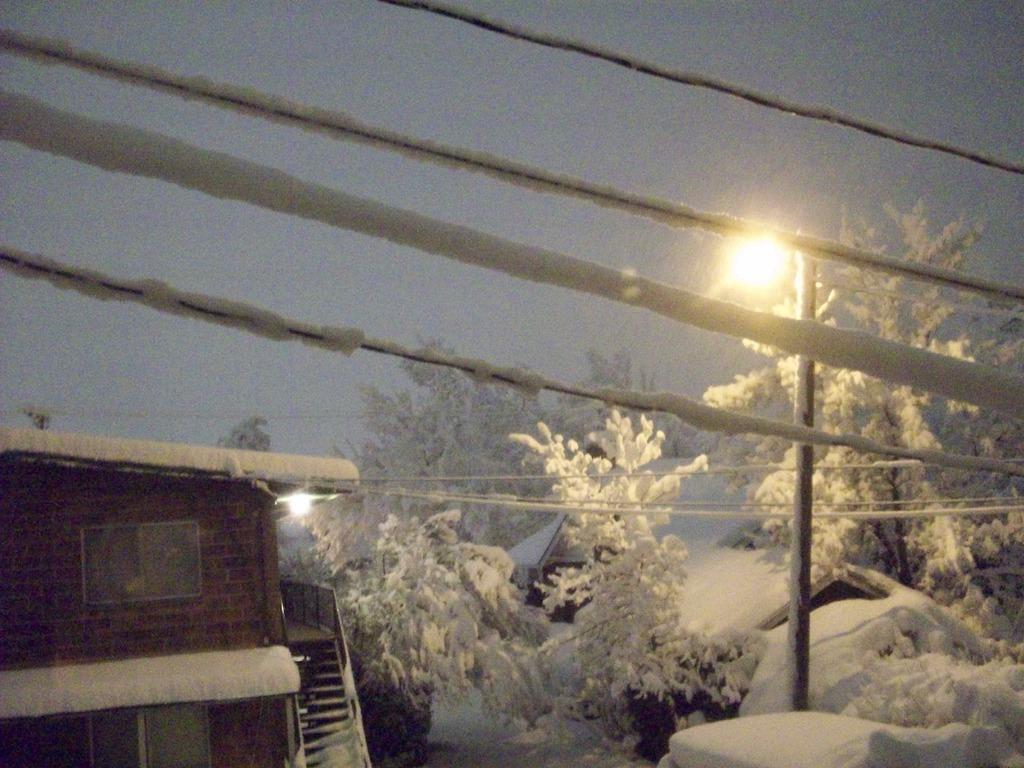Please provide a concise description of this image. This picture is clicked outside. On the right we can see the light, pole and the cables. In the background we can see the sky, trees and houses and we can see the light and we can see the snow and the stairway. 